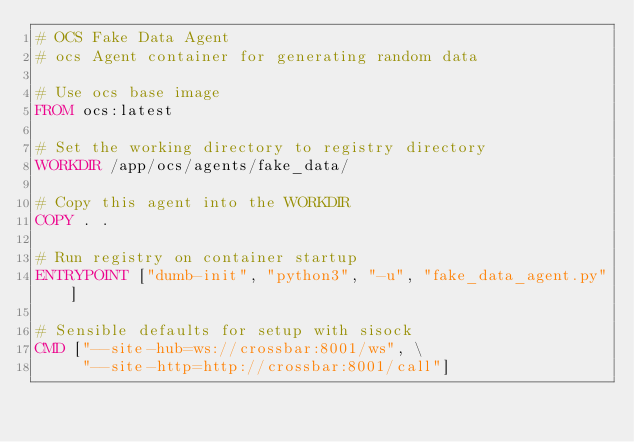<code> <loc_0><loc_0><loc_500><loc_500><_Dockerfile_># OCS Fake Data Agent
# ocs Agent container for generating random data

# Use ocs base image
FROM ocs:latest

# Set the working directory to registry directory
WORKDIR /app/ocs/agents/fake_data/

# Copy this agent into the WORKDIR
COPY . .

# Run registry on container startup
ENTRYPOINT ["dumb-init", "python3", "-u", "fake_data_agent.py"]

# Sensible defaults for setup with sisock
CMD ["--site-hub=ws://crossbar:8001/ws", \
     "--site-http=http://crossbar:8001/call"]
</code> 